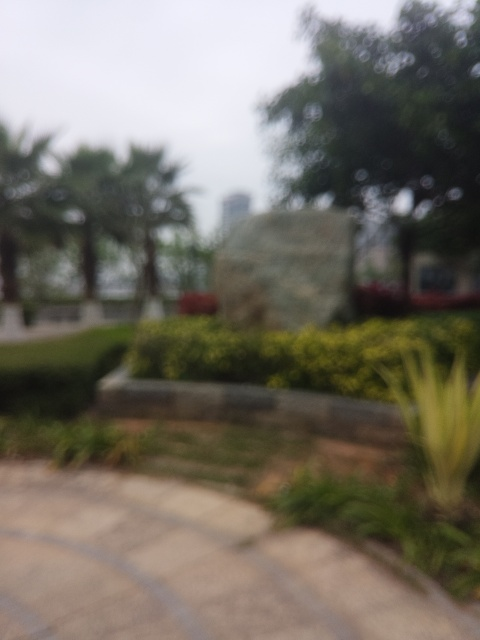What is the overall sharpness of this image?
A. Average
B. Very low
C. Moderate
D. High
Answer with the option's letter from the given choices directly.
 B. 